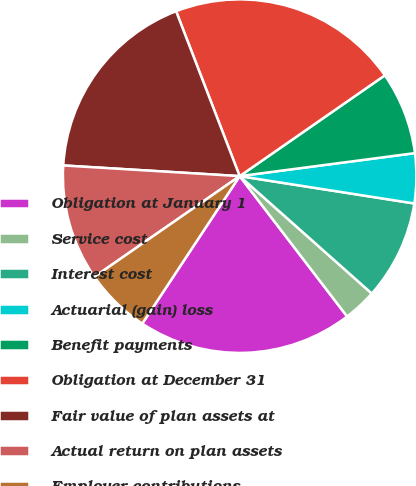Convert chart to OTSL. <chart><loc_0><loc_0><loc_500><loc_500><pie_chart><fcel>Obligation at January 1<fcel>Service cost<fcel>Interest cost<fcel>Actuarial (gain) loss<fcel>Benefit payments<fcel>Obligation at December 31<fcel>Fair value of plan assets at<fcel>Actual return on plan assets<fcel>Employer contributions<nl><fcel>19.69%<fcel>3.04%<fcel>9.09%<fcel>4.55%<fcel>7.58%<fcel>21.2%<fcel>18.18%<fcel>10.61%<fcel>6.06%<nl></chart> 